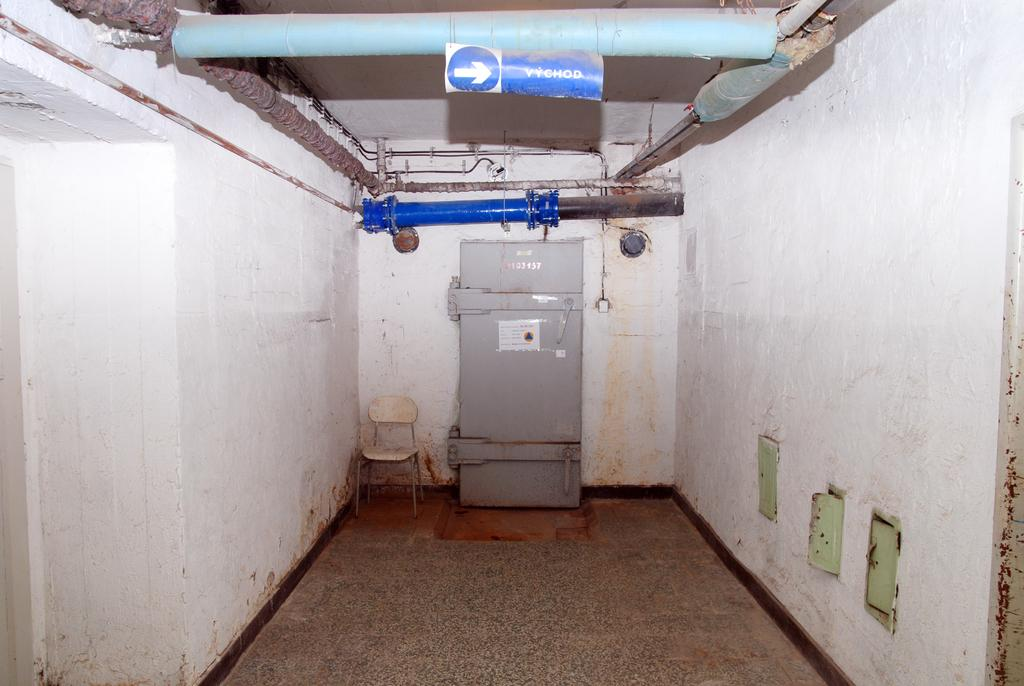<image>
Offer a succinct explanation of the picture presented. A sign hanging in a grim dirty industrial chamber reads VYCHOD. 